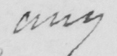Please provide the text content of this handwritten line. any 